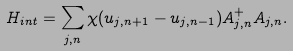Convert formula to latex. <formula><loc_0><loc_0><loc_500><loc_500>H _ { i n t } = \sum _ { j , n } \chi ( u _ { j , n + 1 } - u _ { j , n - 1 } ) A ^ { + } _ { j , n } A _ { j , n } .</formula> 